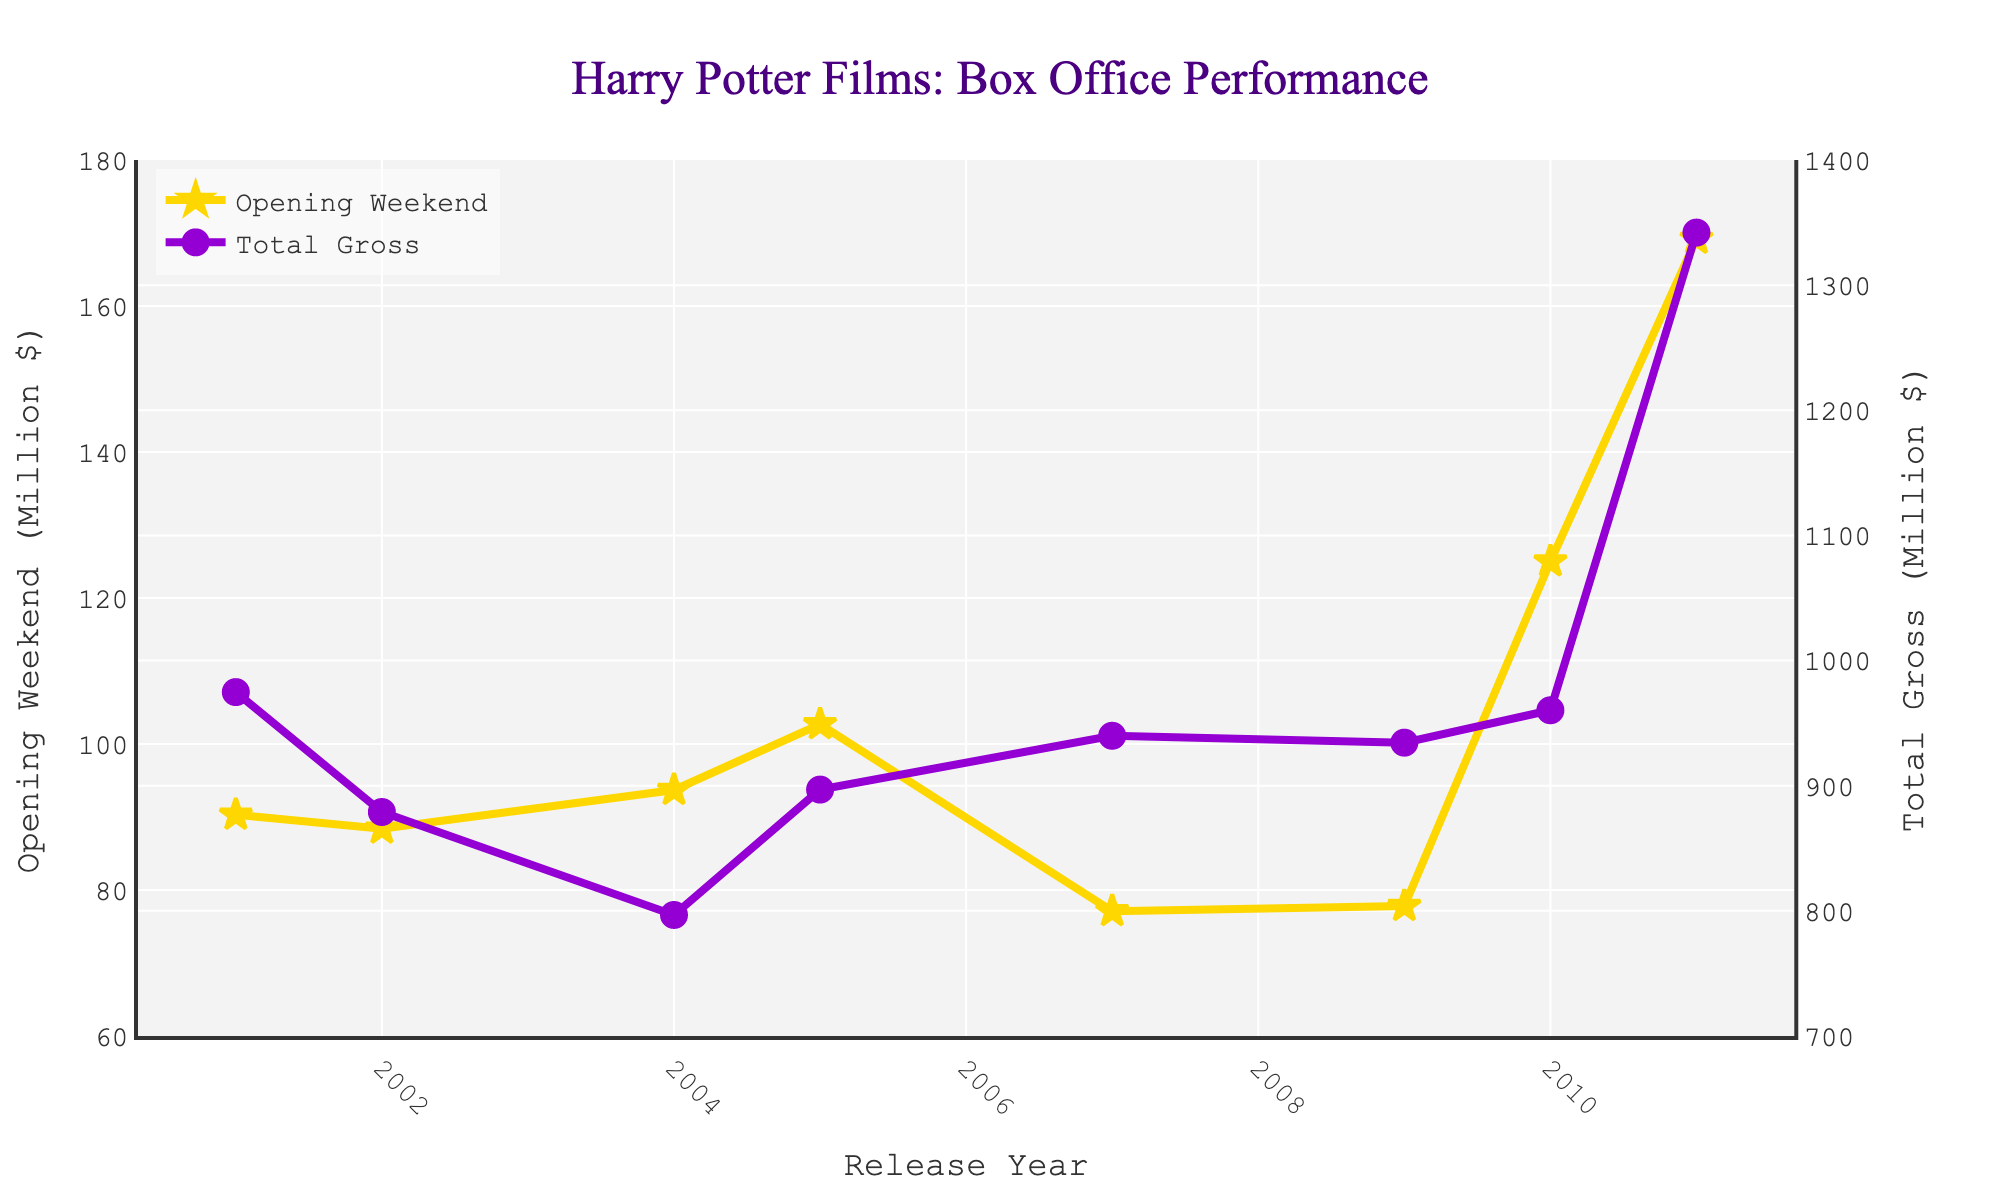Which Harry Potter film had the highest total gross? Look at the line representing the Total Gross. The highest point on this line corresponds to "Harry Potter and the Deathly Hallows - Part 2" with a total gross of 1342.0 million dollars.
Answer: Harry Potter and the Deathly Hallows - Part 2 Which Harry Potter film had the lowest opening weekend earnings? Look at the line representing the Opening Weekend. The lowest point on this line corresponds to "Harry Potter and the Order of the Phoenix" with opening weekend earnings of 77.1 million dollars.
Answer: Harry Potter and the Order of the Phoenix How did the opening weekend earnings change from "Philosopher's Stone" to "Chamber of Secrets"? Compare the opening weekend earnings of the two films. "Philosopher's Stone" had 90.3 million, and "Chamber of Secrets" had 88.4 million. The change is 88.4 million - 90.3 million = -1.9 million.
Answer: Decreased by 1.9 million What is the difference in total gross between "Prisoner of Azkaban" and "Goblet of Fire"? Look at the total gross values for both films. "Prisoner of Azkaban" has 796.7 million and "Goblet of Fire" has 896.9 million. The difference is 896.9 million - 796.7 million = 100.2 million.
Answer: 100.2 million Which film showed the largest opening weekend earnings increase compared to its predecessor? Calculate the difference in opening weekend earnings between consecutive films. The increases are:
- "Philosopher's Stone" to "Chamber of Secrets": -1.9 million
- "Chamber of Secrets" to "Prisoner of Azkaban": 5.3 million
- "Prisoner of Azkaban" to "Goblet of Fire": 9.0 million
- "Goblet of Fire" to "Order of the Phoenix": -25.6 million
- "Order of the Phoenix" to "Half-Blood Prince": 0.7 million
- "Half-Blood Prince" to "Deathly Hallows - Part 1": 47.2 million
- "Deathly Hallows - Part 1" to "Deathly Hallows - Part 2": 44.2 million
The largest increase is from "Half-Blood Prince" to "Deathly Hallows - Part 1" with 47.2 million.
Answer: Deathly Hallows - Part 1 Calculate the average total gross of all the films. Sum the total gross values and divide by the number of films. 
(974.8 + 879.0 + 796.7 + 896.9 + 939.9 + 934.4 + 960.3 + 1342.0) / 8 = 972.0 million.
Answer: 972.0 million Did any film have its total gross lower than 800 million? Check the total gross values for all films. "Harry Potter and the Prisoner of Azkaban" has a total gross of 796.7 million, which is lower than 800 million.
Answer: Yes, Prisoner of Azkaban How many films have a total gross above 900 million? Count the number of films with total gross values over 900 million. The films are:
- Philosopher's Stone (974.8 million)
- Chamber of Secrets (879.0 million) – not above 900 million
- Goblet of Fire (896.9 million) – not above 900 million
- Order of the Phoenix (939.9 million)
- Half-Blood Prince (934.4 million)
- Deathly Hallows - Part 1 (960.3 million)
- Deathly Hallows - Part 2 (1342.0 million)
There are 5 films with total gross above 900 million.
Answer: 5 